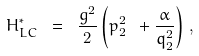Convert formula to latex. <formula><loc_0><loc_0><loc_500><loc_500>H _ { L C } ^ { \ast } \ = \ \frac { g ^ { 2 } } { 2 } \left ( p ^ { 2 } _ { 2 } \ + \frac { \alpha } { q _ { 2 } ^ { 2 } } \right ) \, ,</formula> 